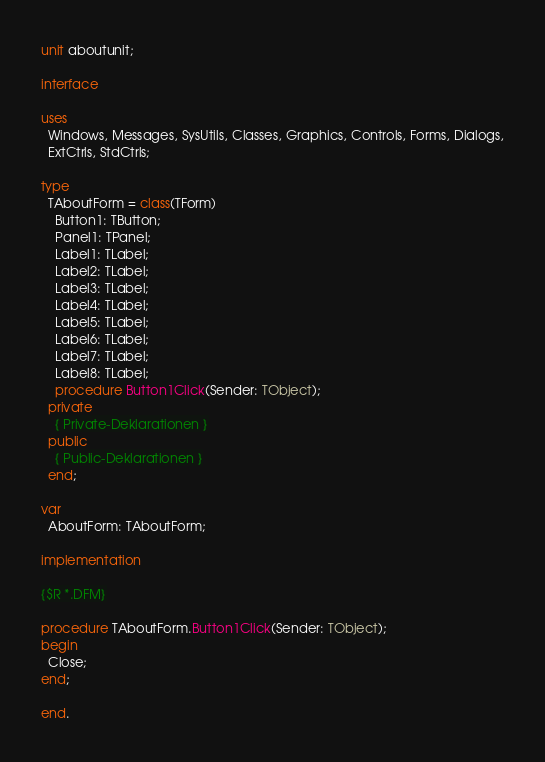<code> <loc_0><loc_0><loc_500><loc_500><_Pascal_>unit aboutunit;

interface

uses
  Windows, Messages, SysUtils, Classes, Graphics, Controls, Forms, Dialogs,
  ExtCtrls, StdCtrls;

type
  TAboutForm = class(TForm)
    Button1: TButton;
    Panel1: TPanel;
    Label1: TLabel;
    Label2: TLabel;
    Label3: TLabel;
    Label4: TLabel;
    Label5: TLabel;
    Label6: TLabel;
    Label7: TLabel;
    Label8: TLabel;
    procedure Button1Click(Sender: TObject);
  private
    { Private-Deklarationen }
  public
    { Public-Deklarationen }
  end;

var
  AboutForm: TAboutForm;

implementation

{$R *.DFM}

procedure TAboutForm.Button1Click(Sender: TObject);
begin
  Close;
end;

end.
</code> 